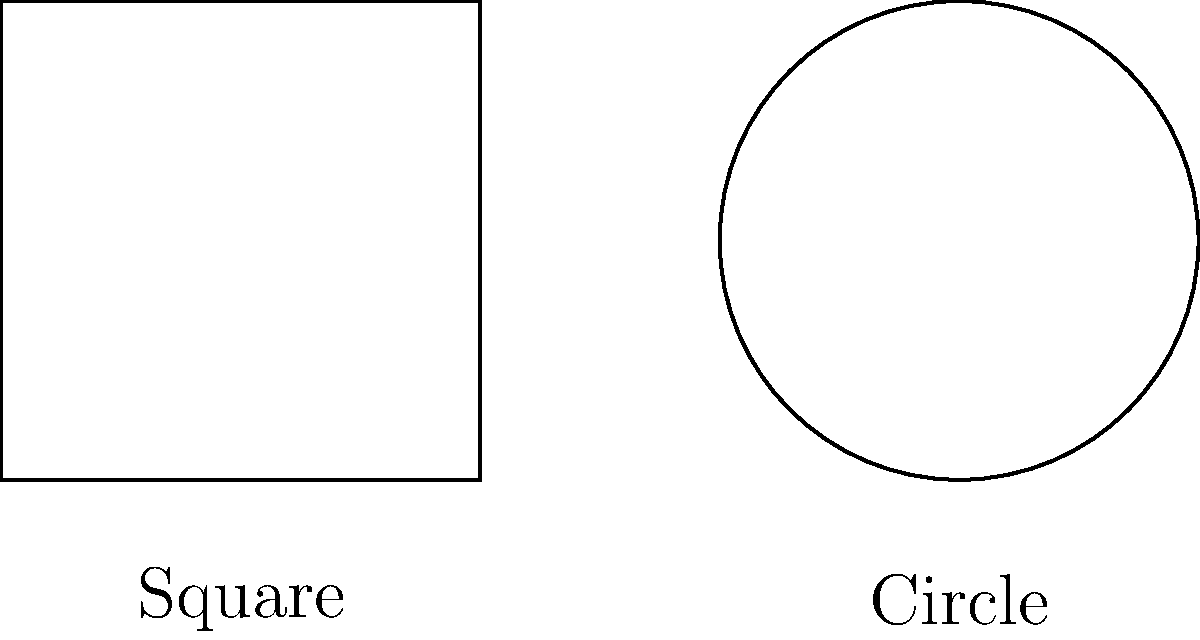Look at these two shapes, dear. The one on the left is called a square, and the one on the right is a circle. Can you tell me which shape has more ways to look the same if you turn it around? Let's think about this step-by-step:

1. First, let's look at the square:
   - If we turn it 90 degrees (a quarter turn), it looks the same.
   - We can do this four times before it's back where it started.
   - We can also flip it over, and it still looks like a square.

2. Now, let's look at the circle:
   - No matter how we turn the circle, it always looks the same.
   - We can turn it any amount, and it still looks like a circle.
   - Even if we flip it over, it's still the same circle.

3. Comparing the two:
   - The square has a few specific ways to look the same (four rotations and some flips).
   - The circle looks the same no matter how we turn it or flip it.

So, the circle has more ways to look the same when we turn it around or flip it. In fact, it has infinitely many ways!
Answer: The circle has more symmetries. 